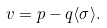<formula> <loc_0><loc_0><loc_500><loc_500>v = p - q \langle \sigma \rangle .</formula> 